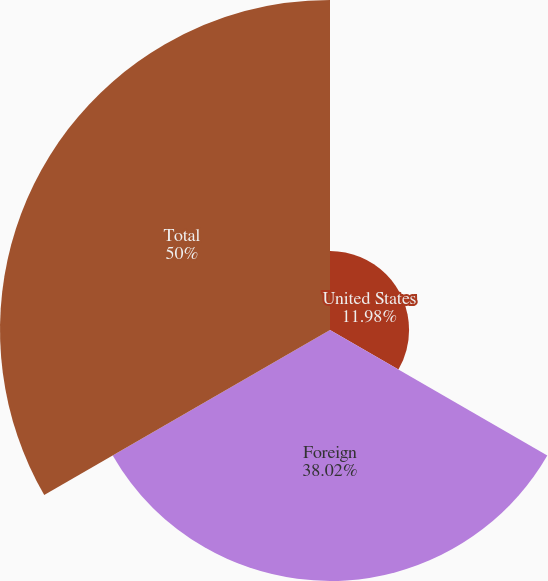Convert chart. <chart><loc_0><loc_0><loc_500><loc_500><pie_chart><fcel>United States<fcel>Foreign<fcel>Total<nl><fcel>11.98%<fcel>38.02%<fcel>50.0%<nl></chart> 